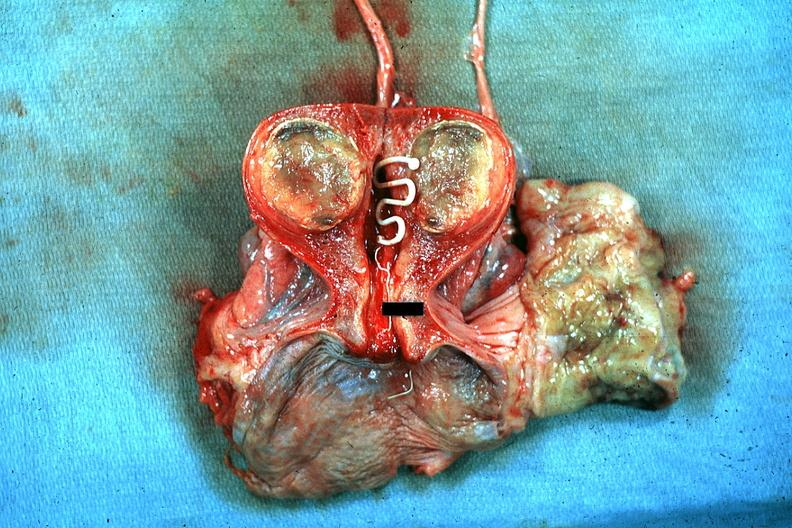does chest and abdomen slide show excellent plastic coil with deep red endometrium and degenerating mural myoma?
Answer the question using a single word or phrase. No 